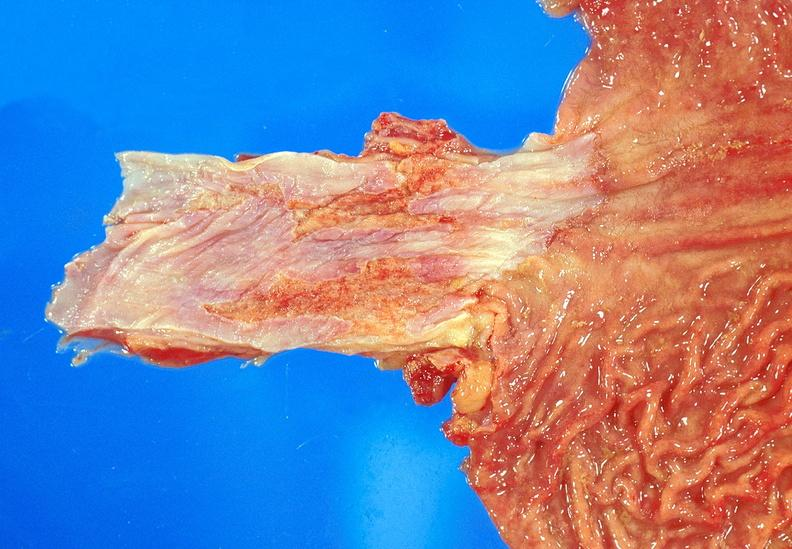does this partially fixed gross show barrett 's esophagus?
Answer the question using a single word or phrase. No 